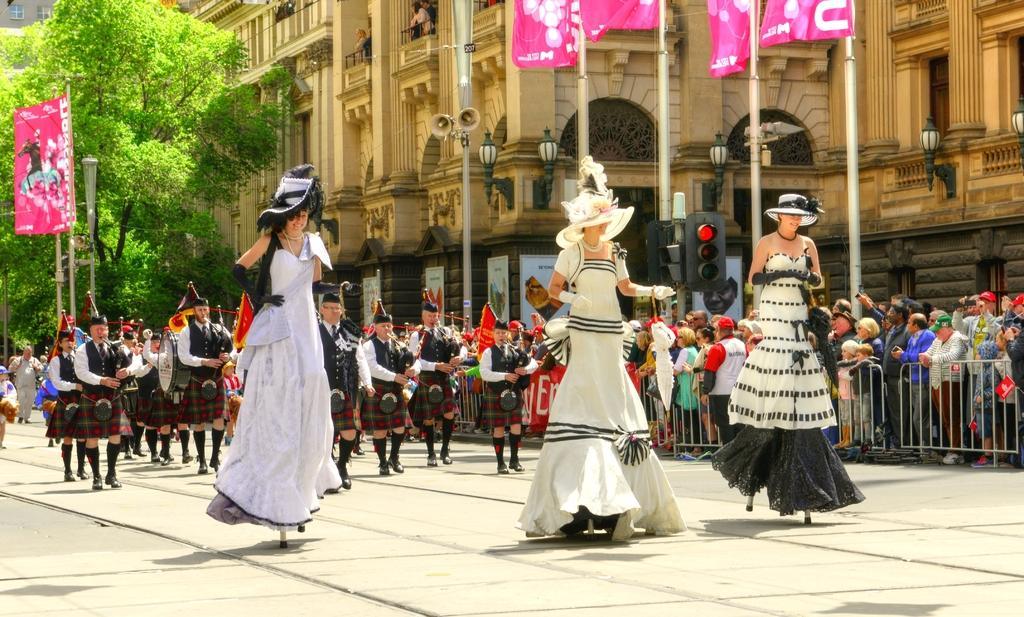In one or two sentences, can you explain what this image depicts? In this picture there are three tall girls in the image, they are wearing costumes and there are other people on the left side of the image and there are flags at the top side of the image and there are lamp poles, traffic poles, and a building in the background area of the image. 